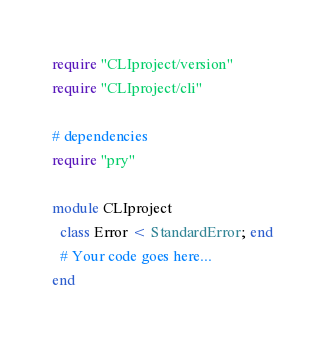<code> <loc_0><loc_0><loc_500><loc_500><_Ruby_>require "CLIproject/version"
require "CLIproject/cli"

# dependencies 
require "pry"

module CLIproject
  class Error < StandardError; end
  # Your code goes here...
end
</code> 